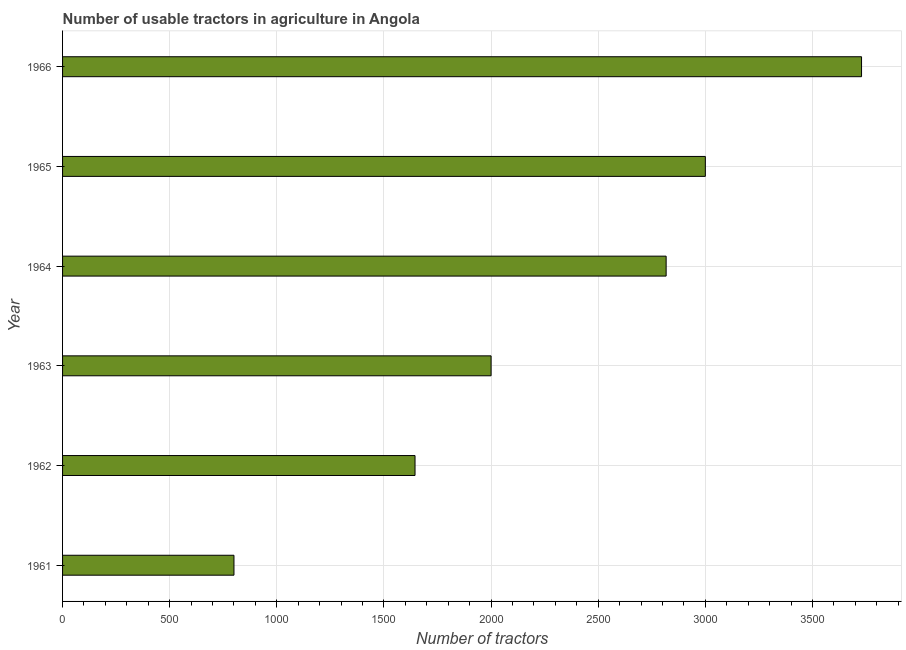Does the graph contain any zero values?
Your answer should be very brief. No. Does the graph contain grids?
Make the answer very short. Yes. What is the title of the graph?
Provide a short and direct response. Number of usable tractors in agriculture in Angola. What is the label or title of the X-axis?
Make the answer very short. Number of tractors. What is the number of tractors in 1962?
Your answer should be very brief. 1645. Across all years, what is the maximum number of tractors?
Give a very brief answer. 3729. Across all years, what is the minimum number of tractors?
Offer a very short reply. 800. In which year was the number of tractors maximum?
Make the answer very short. 1966. In which year was the number of tractors minimum?
Make the answer very short. 1961. What is the sum of the number of tractors?
Offer a very short reply. 1.40e+04. What is the difference between the number of tractors in 1962 and 1966?
Your response must be concise. -2084. What is the average number of tractors per year?
Provide a succinct answer. 2331. What is the median number of tractors?
Make the answer very short. 2408.5. What is the ratio of the number of tractors in 1965 to that in 1966?
Make the answer very short. 0.81. Is the number of tractors in 1963 less than that in 1964?
Offer a very short reply. Yes. What is the difference between the highest and the second highest number of tractors?
Offer a terse response. 729. What is the difference between the highest and the lowest number of tractors?
Your response must be concise. 2929. In how many years, is the number of tractors greater than the average number of tractors taken over all years?
Offer a terse response. 3. Are all the bars in the graph horizontal?
Offer a terse response. Yes. How many years are there in the graph?
Keep it short and to the point. 6. Are the values on the major ticks of X-axis written in scientific E-notation?
Give a very brief answer. No. What is the Number of tractors in 1961?
Provide a succinct answer. 800. What is the Number of tractors of 1962?
Keep it short and to the point. 1645. What is the Number of tractors in 1963?
Give a very brief answer. 2000. What is the Number of tractors in 1964?
Your response must be concise. 2817. What is the Number of tractors of 1965?
Offer a very short reply. 3000. What is the Number of tractors in 1966?
Provide a short and direct response. 3729. What is the difference between the Number of tractors in 1961 and 1962?
Your answer should be very brief. -845. What is the difference between the Number of tractors in 1961 and 1963?
Keep it short and to the point. -1200. What is the difference between the Number of tractors in 1961 and 1964?
Your answer should be very brief. -2017. What is the difference between the Number of tractors in 1961 and 1965?
Make the answer very short. -2200. What is the difference between the Number of tractors in 1961 and 1966?
Your answer should be very brief. -2929. What is the difference between the Number of tractors in 1962 and 1963?
Your response must be concise. -355. What is the difference between the Number of tractors in 1962 and 1964?
Make the answer very short. -1172. What is the difference between the Number of tractors in 1962 and 1965?
Provide a succinct answer. -1355. What is the difference between the Number of tractors in 1962 and 1966?
Your answer should be compact. -2084. What is the difference between the Number of tractors in 1963 and 1964?
Provide a succinct answer. -817. What is the difference between the Number of tractors in 1963 and 1965?
Offer a terse response. -1000. What is the difference between the Number of tractors in 1963 and 1966?
Keep it short and to the point. -1729. What is the difference between the Number of tractors in 1964 and 1965?
Ensure brevity in your answer.  -183. What is the difference between the Number of tractors in 1964 and 1966?
Offer a terse response. -912. What is the difference between the Number of tractors in 1965 and 1966?
Provide a short and direct response. -729. What is the ratio of the Number of tractors in 1961 to that in 1962?
Provide a succinct answer. 0.49. What is the ratio of the Number of tractors in 1961 to that in 1964?
Offer a terse response. 0.28. What is the ratio of the Number of tractors in 1961 to that in 1965?
Make the answer very short. 0.27. What is the ratio of the Number of tractors in 1961 to that in 1966?
Offer a terse response. 0.21. What is the ratio of the Number of tractors in 1962 to that in 1963?
Your answer should be very brief. 0.82. What is the ratio of the Number of tractors in 1962 to that in 1964?
Your answer should be compact. 0.58. What is the ratio of the Number of tractors in 1962 to that in 1965?
Your answer should be compact. 0.55. What is the ratio of the Number of tractors in 1962 to that in 1966?
Offer a very short reply. 0.44. What is the ratio of the Number of tractors in 1963 to that in 1964?
Make the answer very short. 0.71. What is the ratio of the Number of tractors in 1963 to that in 1965?
Your answer should be very brief. 0.67. What is the ratio of the Number of tractors in 1963 to that in 1966?
Offer a terse response. 0.54. What is the ratio of the Number of tractors in 1964 to that in 1965?
Your answer should be very brief. 0.94. What is the ratio of the Number of tractors in 1964 to that in 1966?
Give a very brief answer. 0.76. What is the ratio of the Number of tractors in 1965 to that in 1966?
Offer a very short reply. 0.81. 